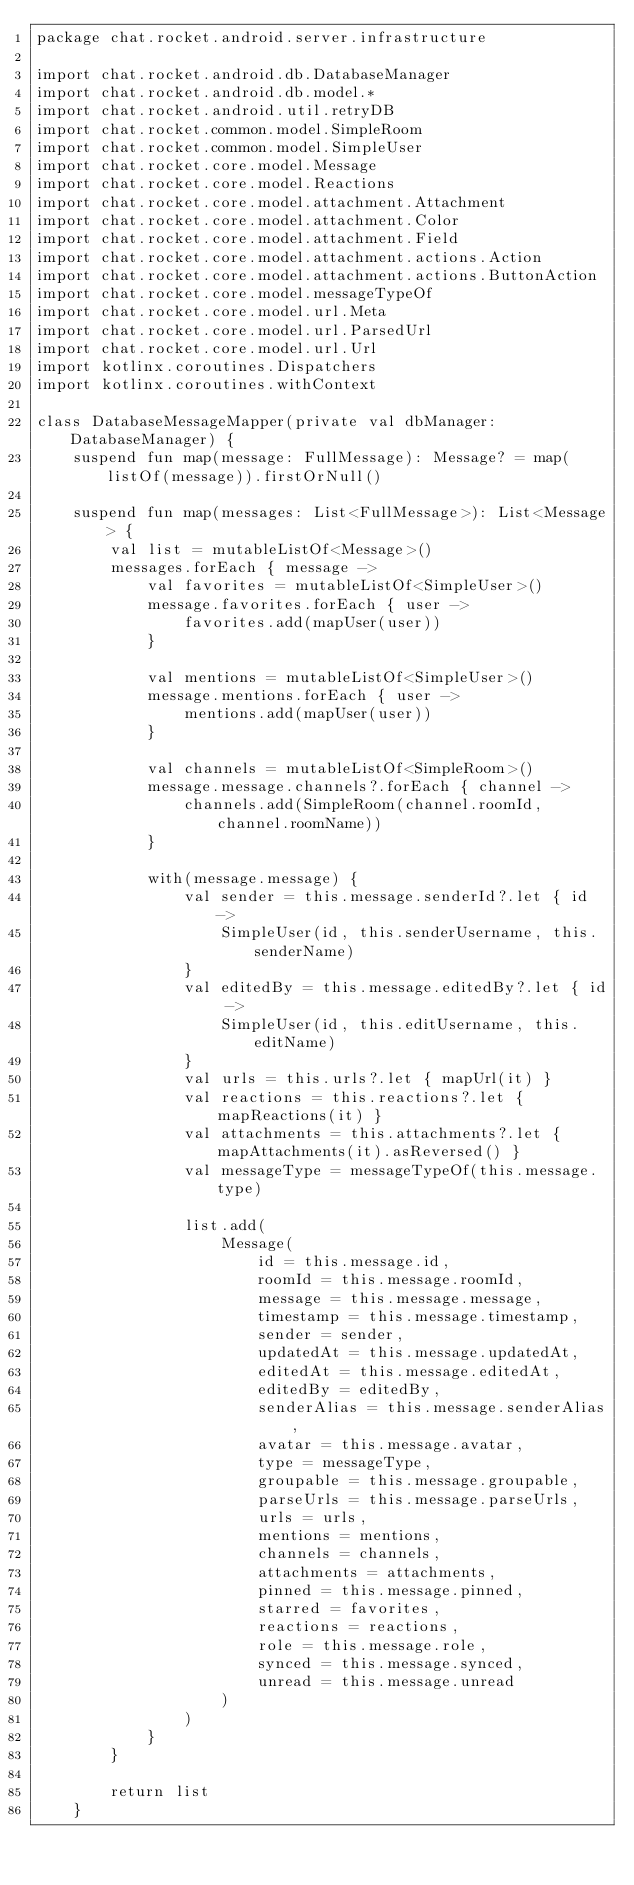<code> <loc_0><loc_0><loc_500><loc_500><_Kotlin_>package chat.rocket.android.server.infrastructure

import chat.rocket.android.db.DatabaseManager
import chat.rocket.android.db.model.*
import chat.rocket.android.util.retryDB
import chat.rocket.common.model.SimpleRoom
import chat.rocket.common.model.SimpleUser
import chat.rocket.core.model.Message
import chat.rocket.core.model.Reactions
import chat.rocket.core.model.attachment.Attachment
import chat.rocket.core.model.attachment.Color
import chat.rocket.core.model.attachment.Field
import chat.rocket.core.model.attachment.actions.Action
import chat.rocket.core.model.attachment.actions.ButtonAction
import chat.rocket.core.model.messageTypeOf
import chat.rocket.core.model.url.Meta
import chat.rocket.core.model.url.ParsedUrl
import chat.rocket.core.model.url.Url
import kotlinx.coroutines.Dispatchers
import kotlinx.coroutines.withContext

class DatabaseMessageMapper(private val dbManager: DatabaseManager) {
    suspend fun map(message: FullMessage): Message? = map(listOf(message)).firstOrNull()

    suspend fun map(messages: List<FullMessage>): List<Message> {
        val list = mutableListOf<Message>()
        messages.forEach { message ->
            val favorites = mutableListOf<SimpleUser>()
            message.favorites.forEach { user ->
                favorites.add(mapUser(user))
            }

            val mentions = mutableListOf<SimpleUser>()
            message.mentions.forEach { user ->
                mentions.add(mapUser(user))
            }

            val channels = mutableListOf<SimpleRoom>()
            message.message.channels?.forEach { channel ->
                channels.add(SimpleRoom(channel.roomId, channel.roomName))
            }

            with(message.message) {
                val sender = this.message.senderId?.let { id ->
                    SimpleUser(id, this.senderUsername, this.senderName)
                }
                val editedBy = this.message.editedBy?.let { id ->
                    SimpleUser(id, this.editUsername, this.editName)
                }
                val urls = this.urls?.let { mapUrl(it) }
                val reactions = this.reactions?.let { mapReactions(it) }
                val attachments = this.attachments?.let { mapAttachments(it).asReversed() }
                val messageType = messageTypeOf(this.message.type)

                list.add(
                    Message(
                        id = this.message.id,
                        roomId = this.message.roomId,
                        message = this.message.message,
                        timestamp = this.message.timestamp,
                        sender = sender,
                        updatedAt = this.message.updatedAt,
                        editedAt = this.message.editedAt,
                        editedBy = editedBy,
                        senderAlias = this.message.senderAlias,
                        avatar = this.message.avatar,
                        type = messageType,
                        groupable = this.message.groupable,
                        parseUrls = this.message.parseUrls,
                        urls = urls,
                        mentions = mentions,
                        channels = channels,
                        attachments = attachments,
                        pinned = this.message.pinned,
                        starred = favorites,
                        reactions = reactions,
                        role = this.message.role,
                        synced = this.message.synced,
                        unread = this.message.unread
                    )
                )
            }
        }

        return list
    }
</code> 